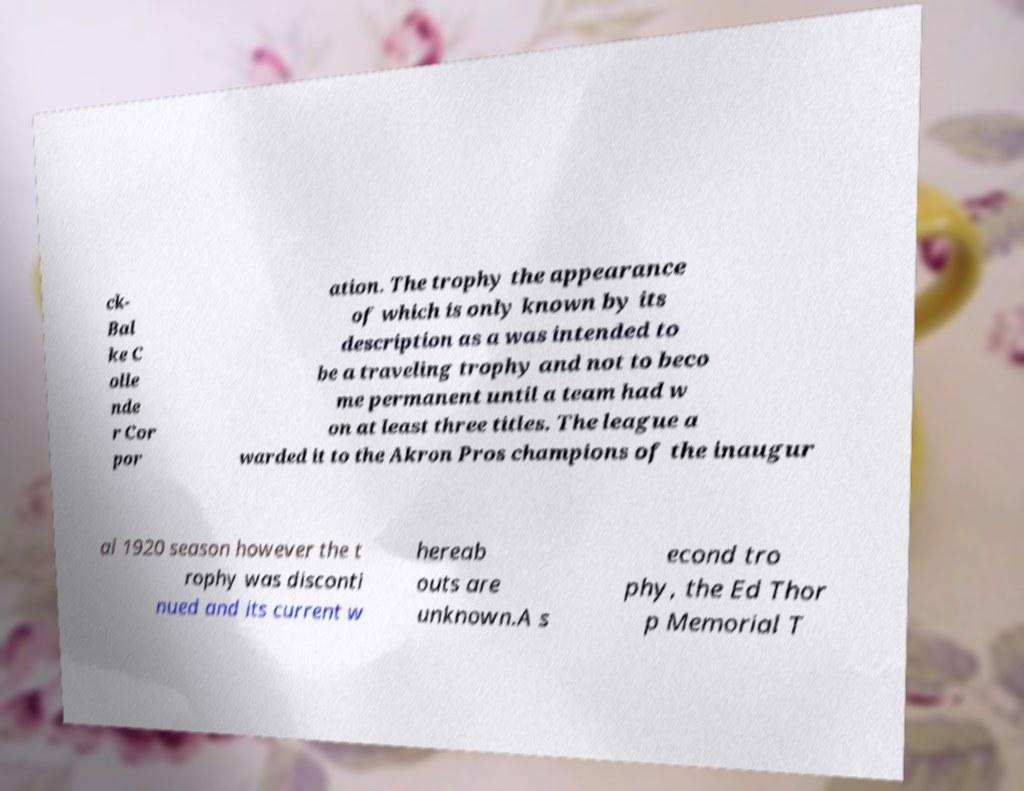Could you extract and type out the text from this image? ck- Bal ke C olle nde r Cor por ation. The trophy the appearance of which is only known by its description as a was intended to be a traveling trophy and not to beco me permanent until a team had w on at least three titles. The league a warded it to the Akron Pros champions of the inaugur al 1920 season however the t rophy was disconti nued and its current w hereab outs are unknown.A s econd tro phy, the Ed Thor p Memorial T 